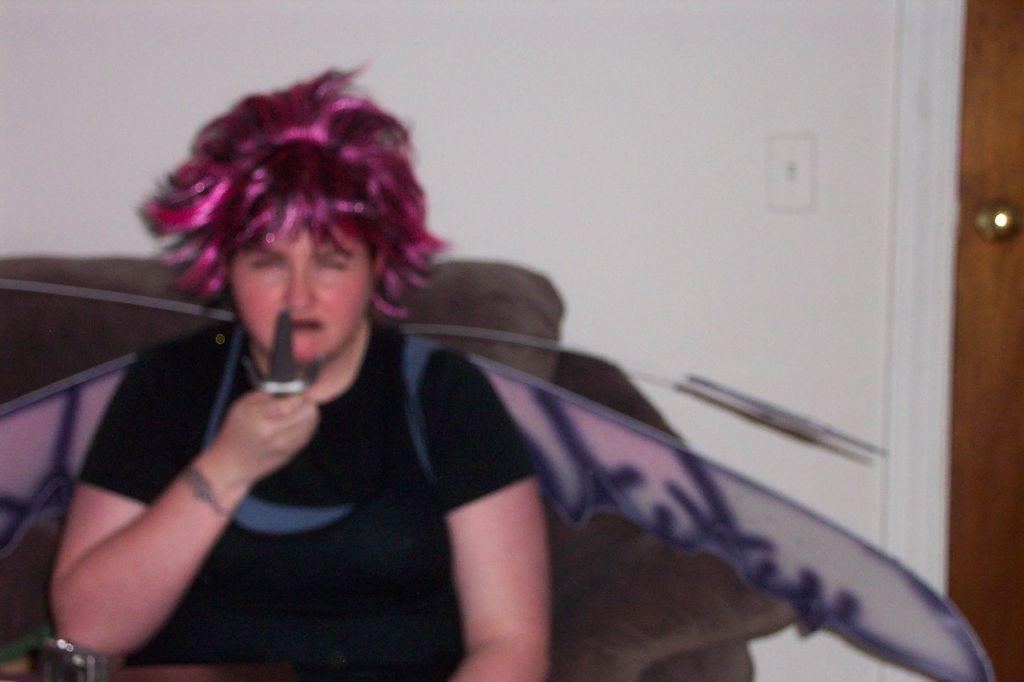Could you give a brief overview of what you see in this image? In the picture I can see a woman wearing black dress is sitting and holding a knife in her hand and there is a door in the right corner. 